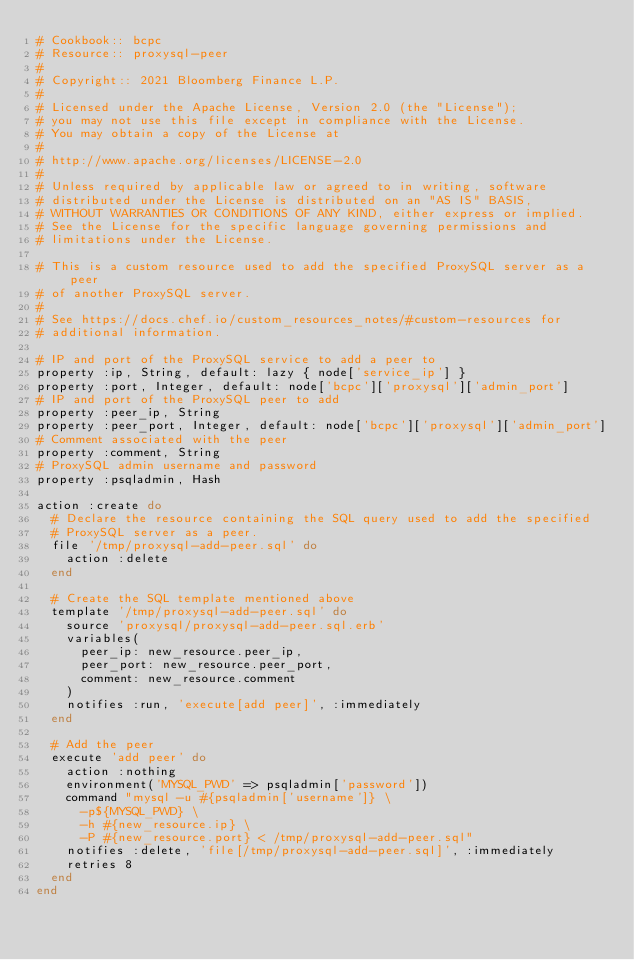<code> <loc_0><loc_0><loc_500><loc_500><_Ruby_># Cookbook:: bcpc
# Resource:: proxysql-peer
#
# Copyright:: 2021 Bloomberg Finance L.P.
#
# Licensed under the Apache License, Version 2.0 (the "License");
# you may not use this file except in compliance with the License.
# You may obtain a copy of the License at
#
# http://www.apache.org/licenses/LICENSE-2.0
#
# Unless required by applicable law or agreed to in writing, software
# distributed under the License is distributed on an "AS IS" BASIS,
# WITHOUT WARRANTIES OR CONDITIONS OF ANY KIND, either express or implied.
# See the License for the specific language governing permissions and
# limitations under the License.

# This is a custom resource used to add the specified ProxySQL server as a peer
# of another ProxySQL server.
#
# See https://docs.chef.io/custom_resources_notes/#custom-resources for
# additional information.

# IP and port of the ProxySQL service to add a peer to
property :ip, String, default: lazy { node['service_ip'] }
property :port, Integer, default: node['bcpc']['proxysql']['admin_port']
# IP and port of the ProxySQL peer to add
property :peer_ip, String
property :peer_port, Integer, default: node['bcpc']['proxysql']['admin_port']
# Comment associated with the peer
property :comment, String
# ProxySQL admin username and password
property :psqladmin, Hash

action :create do
  # Declare the resource containing the SQL query used to add the specified
  # ProxySQL server as a peer.
  file '/tmp/proxysql-add-peer.sql' do
    action :delete
  end

  # Create the SQL template mentioned above
  template '/tmp/proxysql-add-peer.sql' do
    source 'proxysql/proxysql-add-peer.sql.erb'
    variables(
      peer_ip: new_resource.peer_ip,
      peer_port: new_resource.peer_port,
      comment: new_resource.comment
    )
    notifies :run, 'execute[add peer]', :immediately
  end

  # Add the peer
  execute 'add peer' do
    action :nothing
    environment('MYSQL_PWD' => psqladmin['password'])
    command "mysql -u #{psqladmin['username']} \
      -p${MYSQL_PWD} \
      -h #{new_resource.ip} \
      -P #{new_resource.port} < /tmp/proxysql-add-peer.sql"
    notifies :delete, 'file[/tmp/proxysql-add-peer.sql]', :immediately
    retries 8
  end
end
</code> 